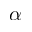Convert formula to latex. <formula><loc_0><loc_0><loc_500><loc_500>\alpha</formula> 